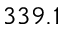Convert formula to latex. <formula><loc_0><loc_0><loc_500><loc_500>3 3 9 . 1</formula> 